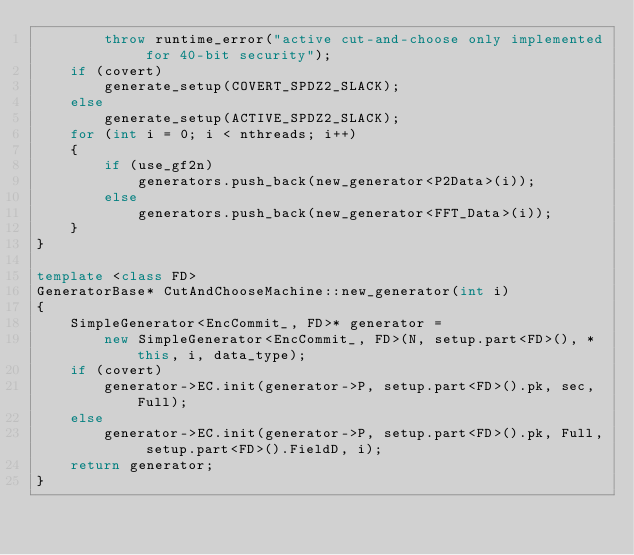<code> <loc_0><loc_0><loc_500><loc_500><_C++_>        throw runtime_error("active cut-and-choose only implemented for 40-bit security");
    if (covert)
        generate_setup(COVERT_SPDZ2_SLACK);
    else
        generate_setup(ACTIVE_SPDZ2_SLACK);
    for (int i = 0; i < nthreads; i++)
    {
        if (use_gf2n)
            generators.push_back(new_generator<P2Data>(i));
        else
            generators.push_back(new_generator<FFT_Data>(i));
    }
}

template <class FD>
GeneratorBase* CutAndChooseMachine::new_generator(int i)
{
    SimpleGenerator<EncCommit_, FD>* generator =
        new SimpleGenerator<EncCommit_, FD>(N, setup.part<FD>(), *this, i, data_type);
    if (covert)
        generator->EC.init(generator->P, setup.part<FD>().pk, sec, Full);
    else
        generator->EC.init(generator->P, setup.part<FD>().pk, Full, setup.part<FD>().FieldD, i);
    return generator;
}
</code> 